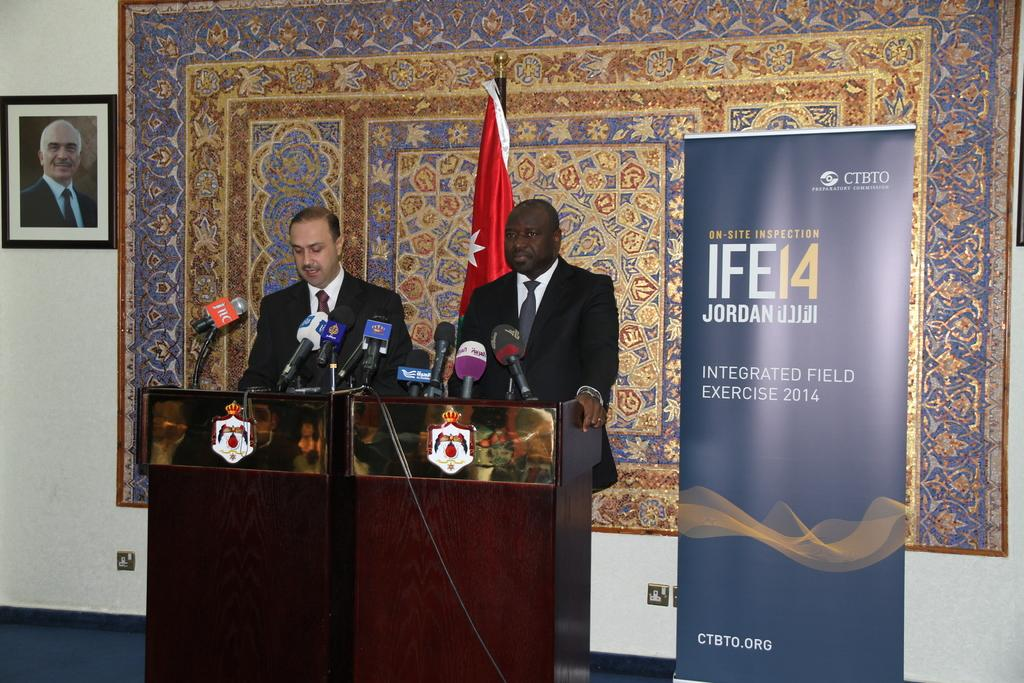Provide a one-sentence caption for the provided image. Two men stand at microphones next to a sign with the year 2014 on it. 